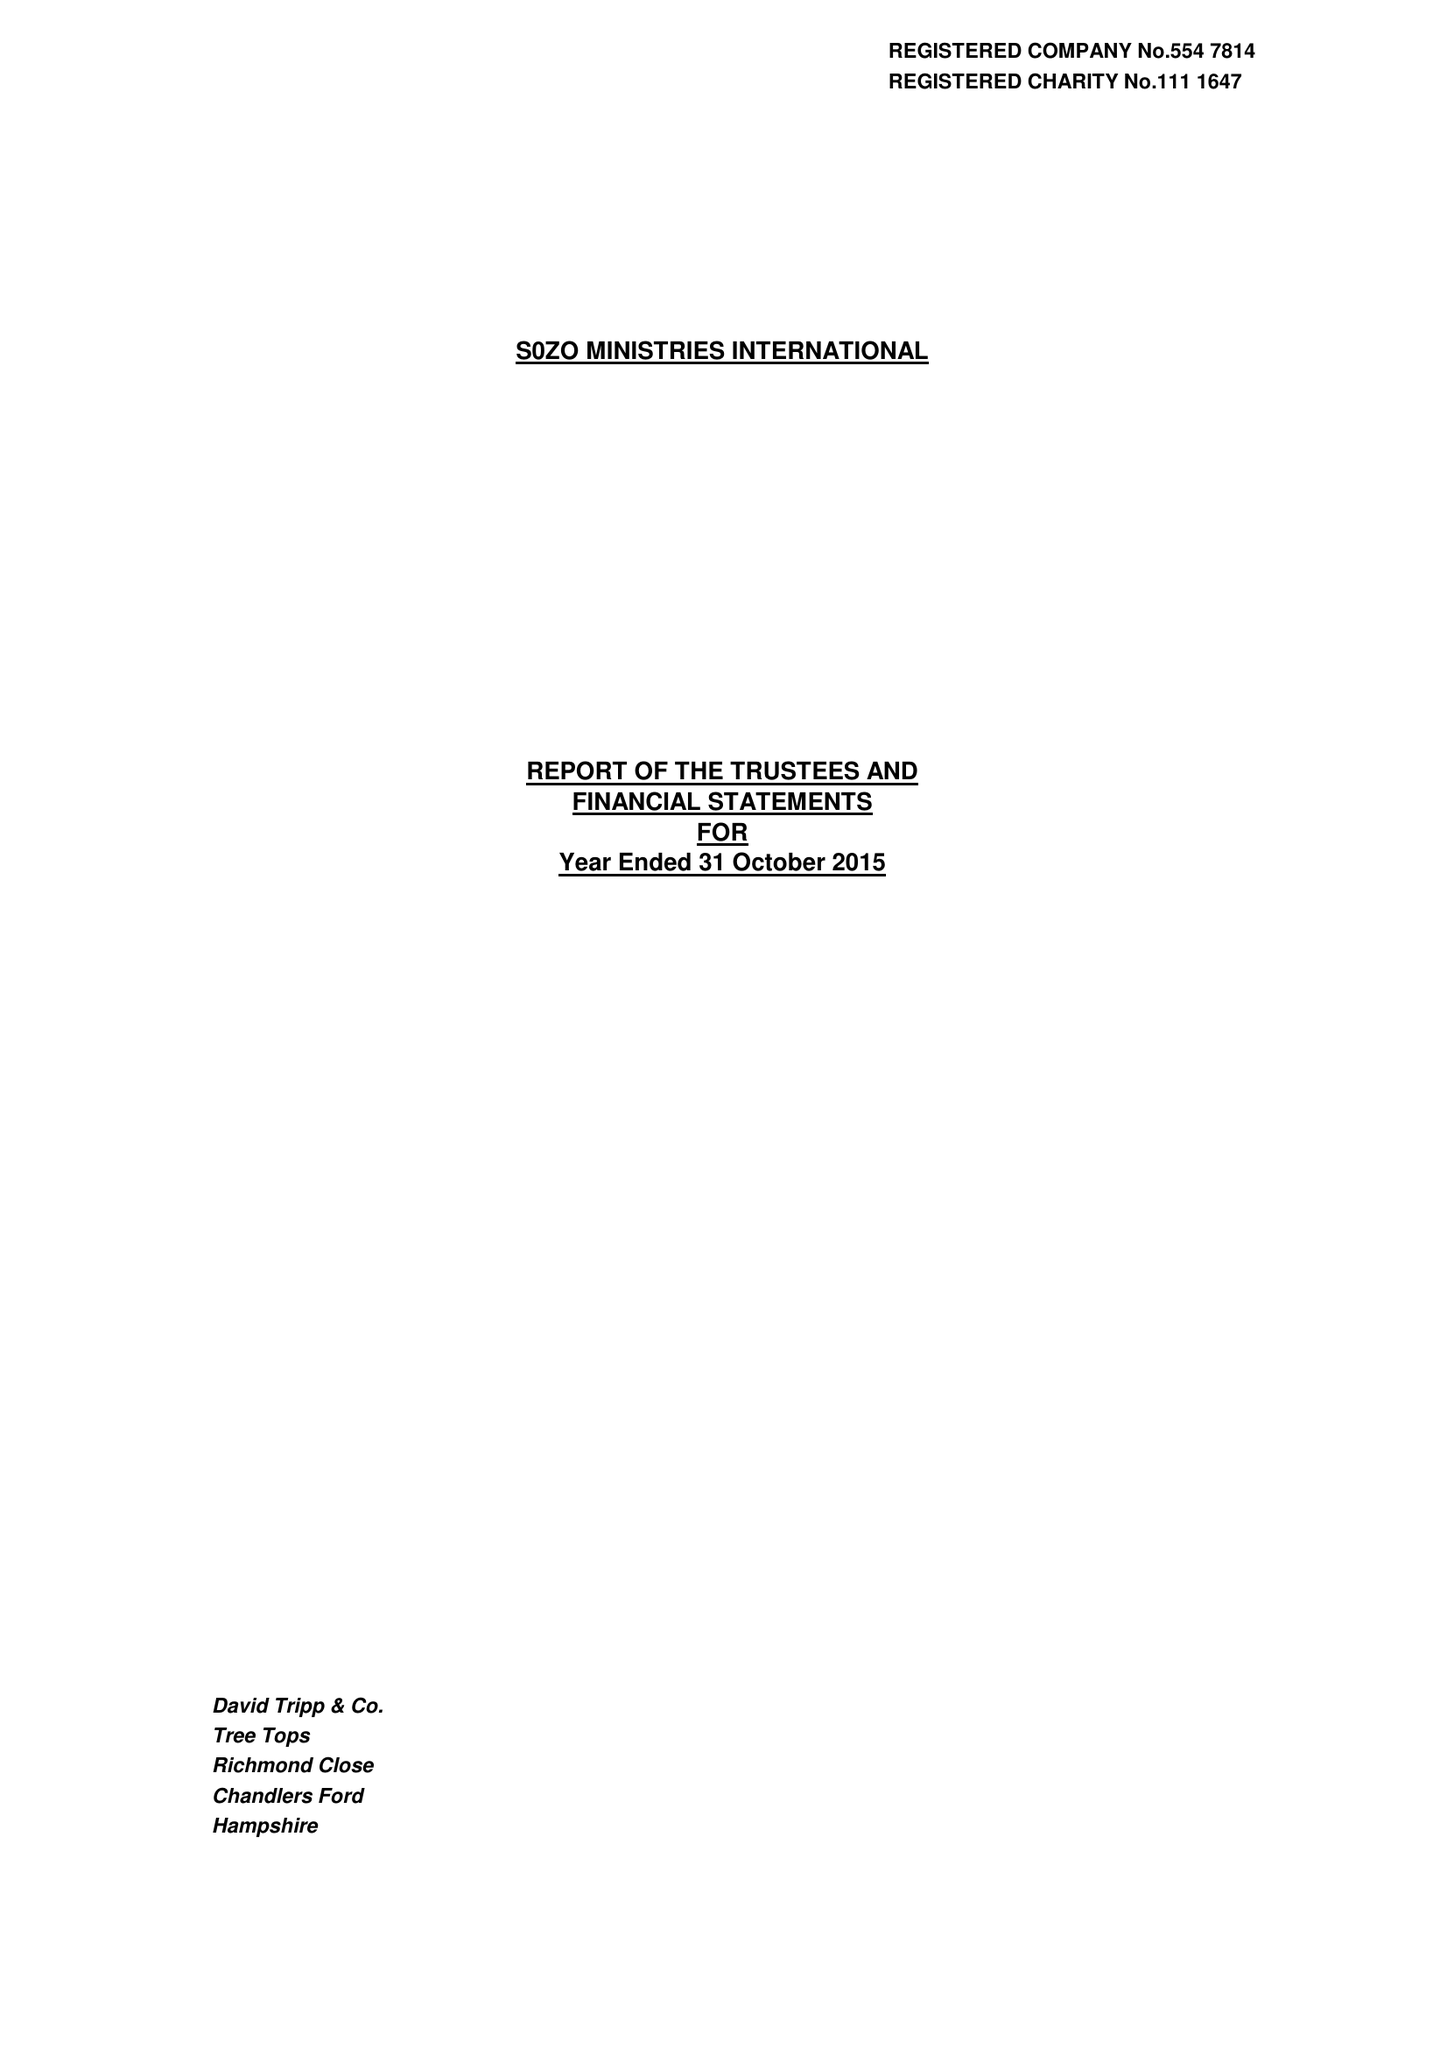What is the value for the spending_annually_in_british_pounds?
Answer the question using a single word or phrase. 273502.00 